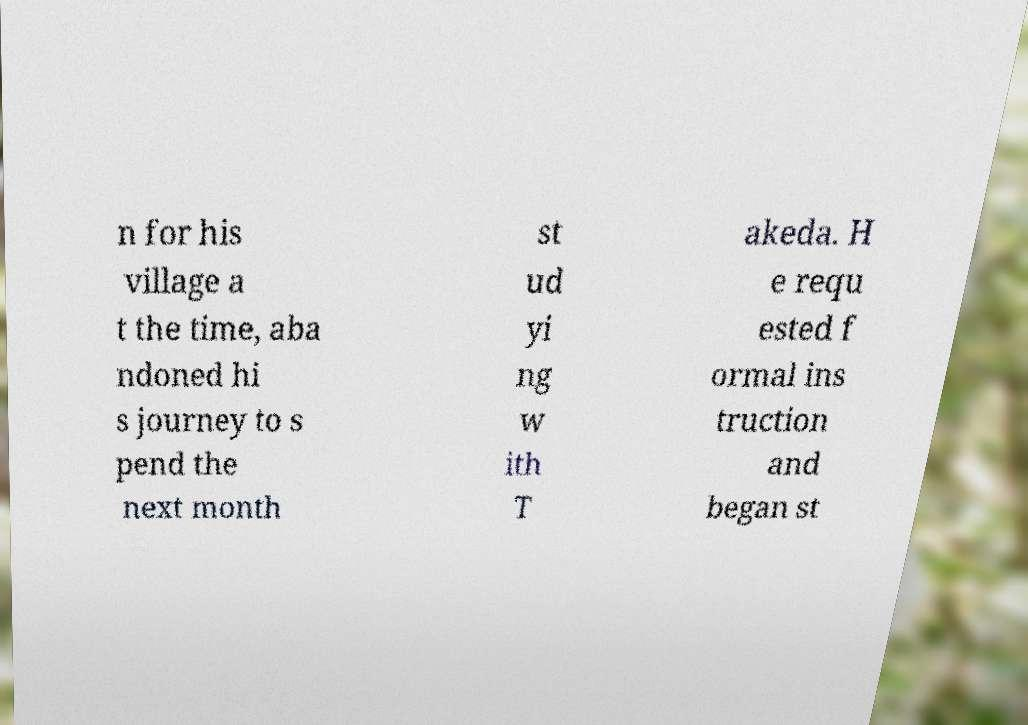Can you accurately transcribe the text from the provided image for me? n for his village a t the time, aba ndoned hi s journey to s pend the next month st ud yi ng w ith T akeda. H e requ ested f ormal ins truction and began st 